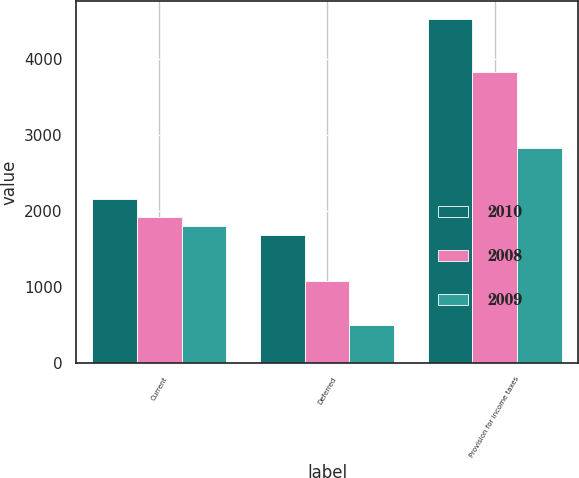<chart> <loc_0><loc_0><loc_500><loc_500><stacked_bar_chart><ecel><fcel>Current<fcel>Deferred<fcel>Provision for income taxes<nl><fcel>2010<fcel>2150<fcel>1676<fcel>4527<nl><fcel>2008<fcel>1922<fcel>1077<fcel>3831<nl><fcel>2009<fcel>1796<fcel>498<fcel>2828<nl></chart> 